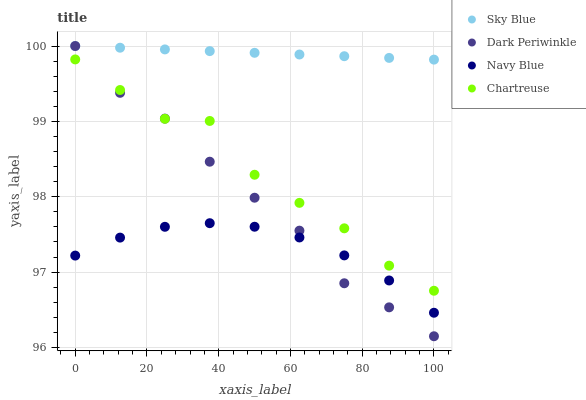Does Navy Blue have the minimum area under the curve?
Answer yes or no. Yes. Does Sky Blue have the maximum area under the curve?
Answer yes or no. Yes. Does Chartreuse have the minimum area under the curve?
Answer yes or no. No. Does Chartreuse have the maximum area under the curve?
Answer yes or no. No. Is Sky Blue the smoothest?
Answer yes or no. Yes. Is Chartreuse the roughest?
Answer yes or no. Yes. Is Dark Periwinkle the smoothest?
Answer yes or no. No. Is Dark Periwinkle the roughest?
Answer yes or no. No. Does Dark Periwinkle have the lowest value?
Answer yes or no. Yes. Does Chartreuse have the lowest value?
Answer yes or no. No. Does Dark Periwinkle have the highest value?
Answer yes or no. Yes. Does Chartreuse have the highest value?
Answer yes or no. No. Is Navy Blue less than Sky Blue?
Answer yes or no. Yes. Is Sky Blue greater than Navy Blue?
Answer yes or no. Yes. Does Dark Periwinkle intersect Navy Blue?
Answer yes or no. Yes. Is Dark Periwinkle less than Navy Blue?
Answer yes or no. No. Is Dark Periwinkle greater than Navy Blue?
Answer yes or no. No. Does Navy Blue intersect Sky Blue?
Answer yes or no. No. 